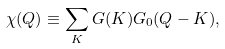<formula> <loc_0><loc_0><loc_500><loc_500>\chi ( Q ) \equiv \sum _ { K } G ( K ) G _ { 0 } ( Q - K ) ,</formula> 